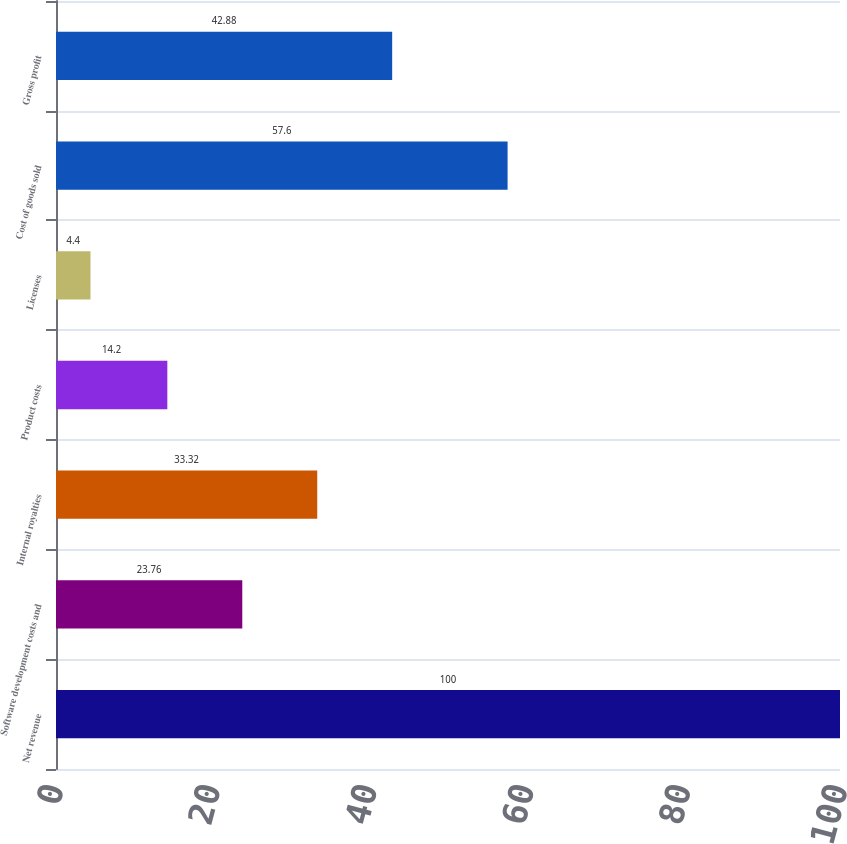Convert chart to OTSL. <chart><loc_0><loc_0><loc_500><loc_500><bar_chart><fcel>Net revenue<fcel>Software development costs and<fcel>Internal royalties<fcel>Product costs<fcel>Licenses<fcel>Cost of goods sold<fcel>Gross profit<nl><fcel>100<fcel>23.76<fcel>33.32<fcel>14.2<fcel>4.4<fcel>57.6<fcel>42.88<nl></chart> 